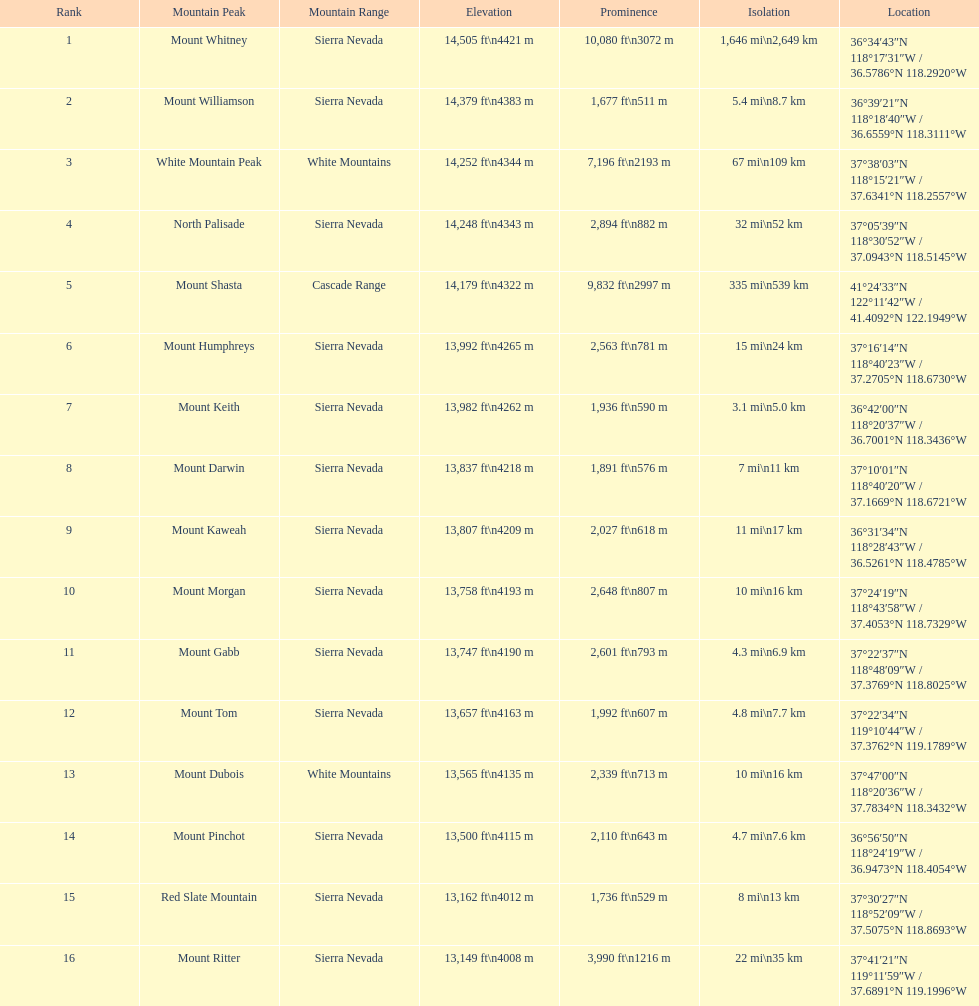How much taller is the mountain peak of mount williamson than that of mount keith? 397 ft. 